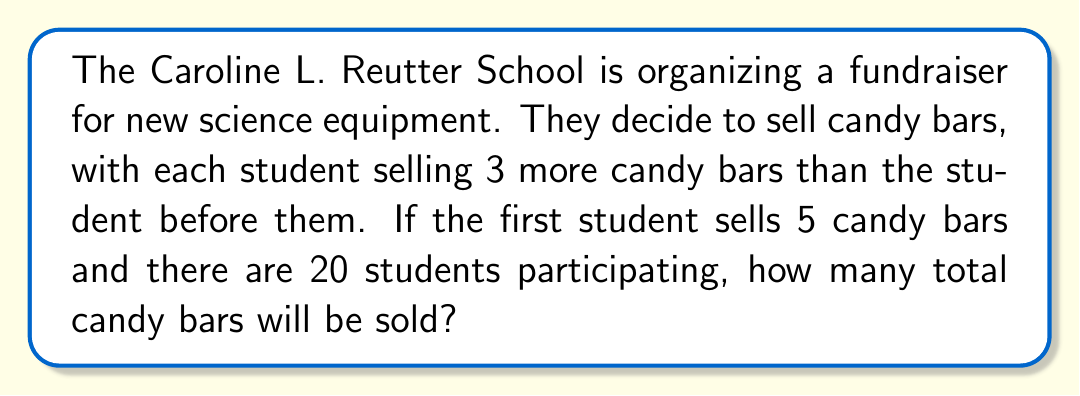Can you answer this question? Let's approach this step-by-step:

1) This is an arithmetic progression problem. In an arithmetic progression, each term differs from the previous term by a constant amount.

2) Let's define our arithmetic sequence:
   $a_1 = 5$ (first student sells 5 candy bars)
   $d = 3$ (common difference, each student sells 3 more than the previous)
   $n = 20$ (number of students)

3) We need to find the sum of this arithmetic sequence. The formula for the sum of an arithmetic sequence is:

   $S_n = \frac{n}{2}(a_1 + a_n)$

   Where $a_n$ is the last term of the sequence.

4) To find $a_n$, we can use the arithmetic sequence formula:
   $a_n = a_1 + (n-1)d$
   $a_{20} = 5 + (20-1)3 = 5 + 57 = 62$

5) Now we can plug this into our sum formula:

   $S_{20} = \frac{20}{2}(5 + 62) = 10(67) = 670$

Therefore, the total number of candy bars sold will be 670.
Answer: 670 candy bars 